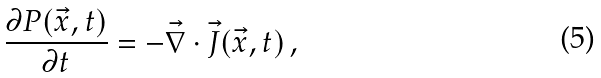Convert formula to latex. <formula><loc_0><loc_0><loc_500><loc_500>\frac { \partial P ( \vec { x } , t ) } { \partial t } = - \vec { \nabla } \cdot \vec { J } ( \vec { x } , t ) \, ,</formula> 